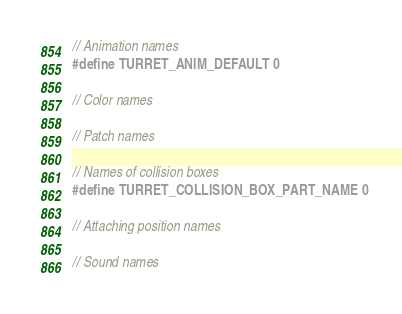Convert code to text. <code><loc_0><loc_0><loc_500><loc_500><_C_>// Animation names
#define TURRET_ANIM_DEFAULT 0

// Color names

// Patch names

// Names of collision boxes
#define TURRET_COLLISION_BOX_PART_NAME 0

// Attaching position names

// Sound names
</code> 